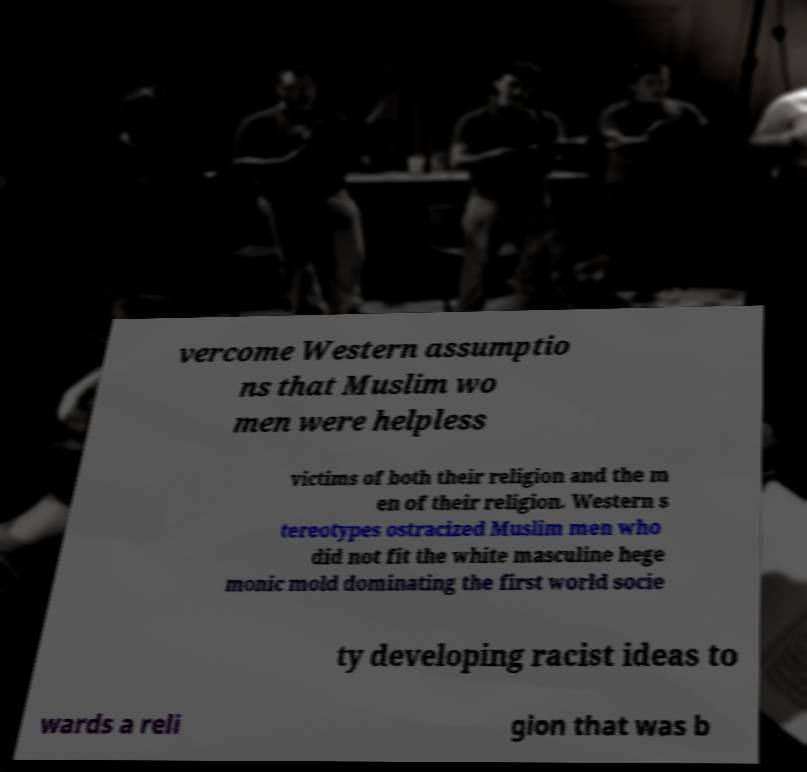Please read and relay the text visible in this image. What does it say? vercome Western assumptio ns that Muslim wo men were helpless victims of both their religion and the m en of their religion. Western s tereotypes ostracized Muslim men who did not fit the white masculine hege monic mold dominating the first world socie ty developing racist ideas to wards a reli gion that was b 